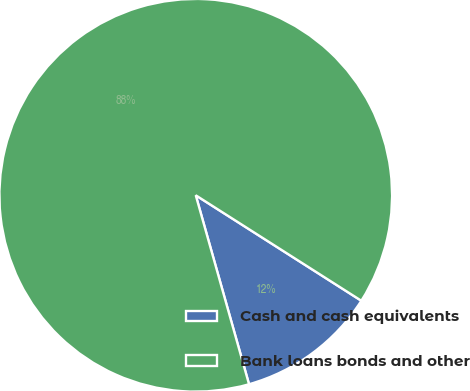<chart> <loc_0><loc_0><loc_500><loc_500><pie_chart><fcel>Cash and cash equivalents<fcel>Bank loans bonds and other<nl><fcel>11.6%<fcel>88.4%<nl></chart> 